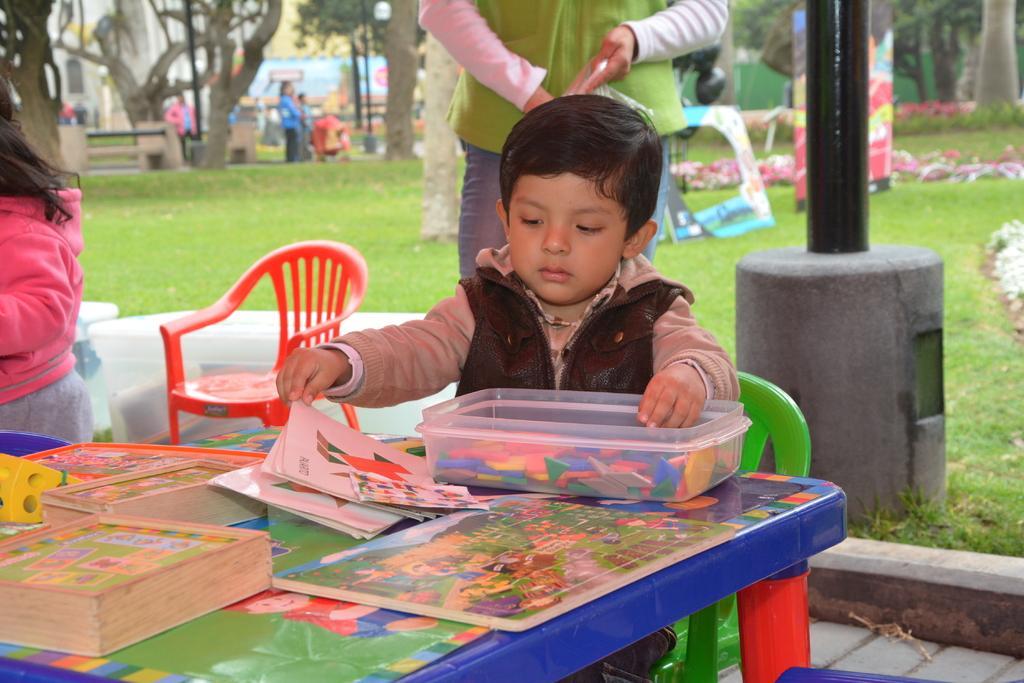Please provide a concise description of this image. In this picture we can see group of people in the middle of the given image a boy is seated on the chair, in front of him we can see a box and couple of papers on the table, in the background we can see some boxes, trees, and couple of poles. 